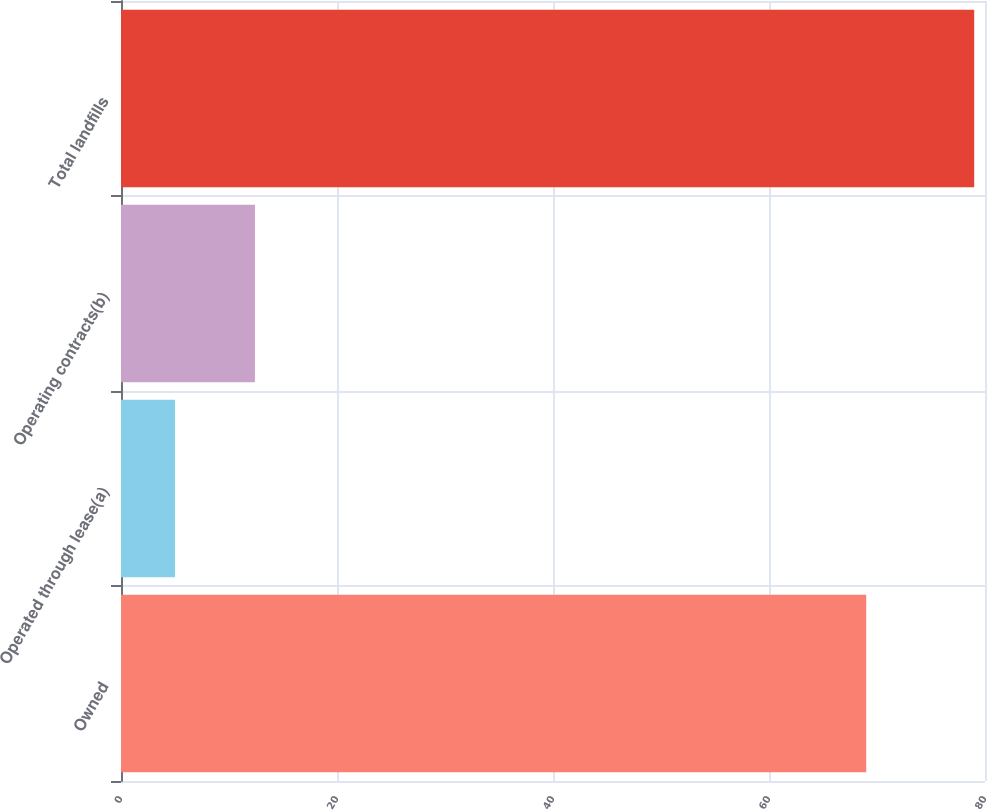<chart> <loc_0><loc_0><loc_500><loc_500><bar_chart><fcel>Owned<fcel>Operated through lease(a)<fcel>Operating contracts(b)<fcel>Total landfills<nl><fcel>69<fcel>5<fcel>12.4<fcel>79<nl></chart> 